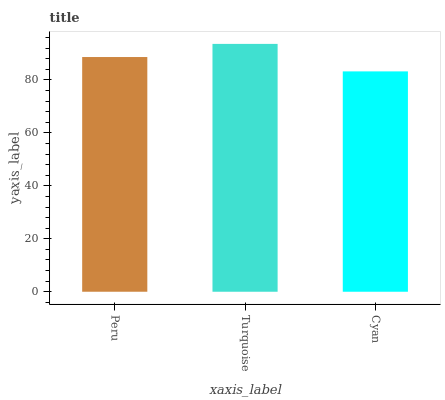Is Turquoise the minimum?
Answer yes or no. No. Is Cyan the maximum?
Answer yes or no. No. Is Turquoise greater than Cyan?
Answer yes or no. Yes. Is Cyan less than Turquoise?
Answer yes or no. Yes. Is Cyan greater than Turquoise?
Answer yes or no. No. Is Turquoise less than Cyan?
Answer yes or no. No. Is Peru the high median?
Answer yes or no. Yes. Is Peru the low median?
Answer yes or no. Yes. Is Cyan the high median?
Answer yes or no. No. Is Cyan the low median?
Answer yes or no. No. 